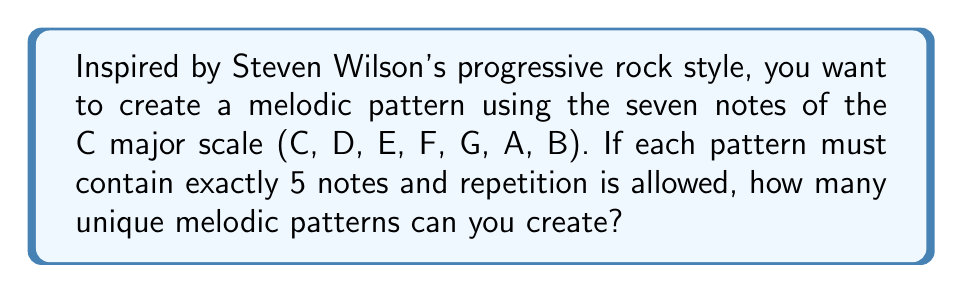Provide a solution to this math problem. Let's approach this step-by-step:

1) We are selecting 5 notes from a set of 7 notes (C major scale).

2) Each position in the pattern can be filled by any of the 7 notes.

3) Repetition is allowed, which means we can use the same note multiple times in a pattern.

4) This scenario is a perfect example of the multiplication principle in combinatorics.

5) For each of the 5 positions in our pattern, we have 7 choices.

6) Therefore, the total number of possible patterns is:

   $$7 \times 7 \times 7 \times 7 \times 7 = 7^5$$

7) Let's calculate this:
   $$7^5 = 7 \times 7 \times 7 \times 7 \times 7 = 16,807$$

Thus, there are 16,807 unique melodic patterns possible under these conditions.
Answer: 16,807 